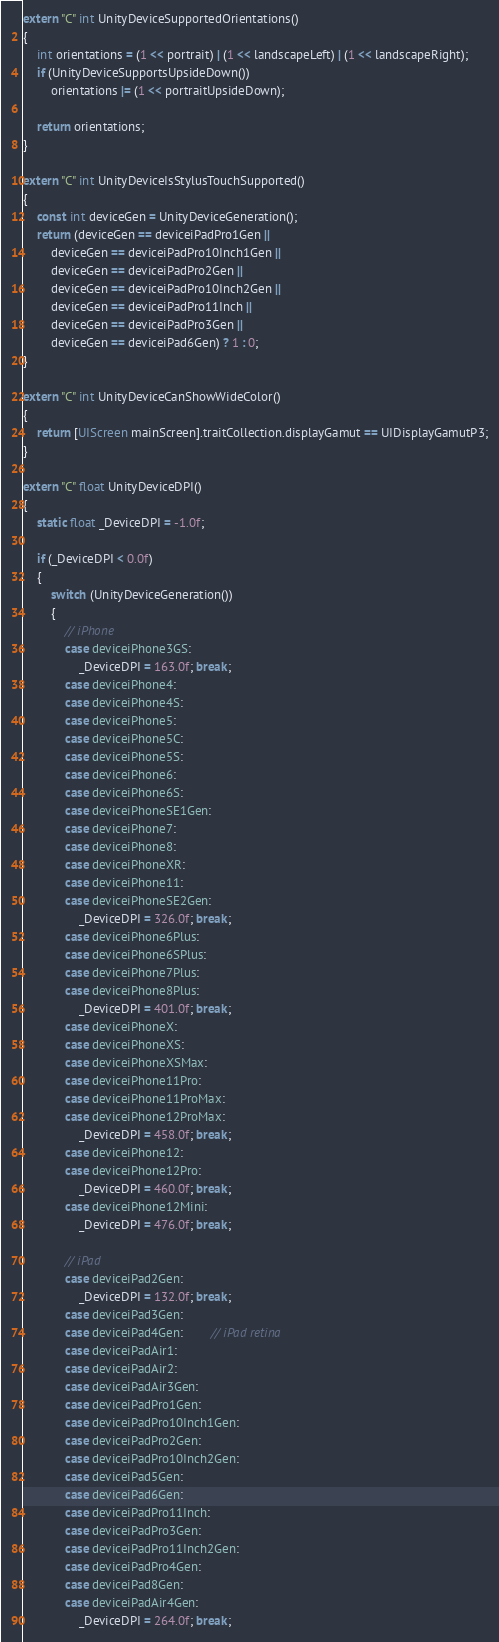Convert code to text. <code><loc_0><loc_0><loc_500><loc_500><_ObjectiveC_>extern "C" int UnityDeviceSupportedOrientations()
{
    int orientations = (1 << portrait) | (1 << landscapeLeft) | (1 << landscapeRight);
    if (UnityDeviceSupportsUpsideDown())
        orientations |= (1 << portraitUpsideDown);

    return orientations;
}

extern "C" int UnityDeviceIsStylusTouchSupported()
{
    const int deviceGen = UnityDeviceGeneration();
    return (deviceGen == deviceiPadPro1Gen ||
        deviceGen == deviceiPadPro10Inch1Gen ||
        deviceGen == deviceiPadPro2Gen ||
        deviceGen == deviceiPadPro10Inch2Gen ||
        deviceGen == deviceiPadPro11Inch ||
        deviceGen == deviceiPadPro3Gen ||
        deviceGen == deviceiPad6Gen) ? 1 : 0;
}

extern "C" int UnityDeviceCanShowWideColor()
{
    return [UIScreen mainScreen].traitCollection.displayGamut == UIDisplayGamutP3;
}

extern "C" float UnityDeviceDPI()
{
    static float _DeviceDPI = -1.0f;

    if (_DeviceDPI < 0.0f)
    {
        switch (UnityDeviceGeneration())
        {
            // iPhone
            case deviceiPhone3GS:
                _DeviceDPI = 163.0f; break;
            case deviceiPhone4:
            case deviceiPhone4S:
            case deviceiPhone5:
            case deviceiPhone5C:
            case deviceiPhone5S:
            case deviceiPhone6:
            case deviceiPhone6S:
            case deviceiPhoneSE1Gen:
            case deviceiPhone7:
            case deviceiPhone8:
            case deviceiPhoneXR:
            case deviceiPhone11:
            case deviceiPhoneSE2Gen:
                _DeviceDPI = 326.0f; break;
            case deviceiPhone6Plus:
            case deviceiPhone6SPlus:
            case deviceiPhone7Plus:
            case deviceiPhone8Plus:
                _DeviceDPI = 401.0f; break;
            case deviceiPhoneX:
            case deviceiPhoneXS:
            case deviceiPhoneXSMax:
            case deviceiPhone11Pro:
            case deviceiPhone11ProMax:
            case deviceiPhone12ProMax:
                _DeviceDPI = 458.0f; break;
            case deviceiPhone12:
            case deviceiPhone12Pro:
                _DeviceDPI = 460.0f; break;
            case deviceiPhone12Mini:
                _DeviceDPI = 476.0f; break;

            // iPad
            case deviceiPad2Gen:
                _DeviceDPI = 132.0f; break;
            case deviceiPad3Gen:
            case deviceiPad4Gen:        // iPad retina
            case deviceiPadAir1:
            case deviceiPadAir2:
            case deviceiPadAir3Gen:
            case deviceiPadPro1Gen:
            case deviceiPadPro10Inch1Gen:
            case deviceiPadPro2Gen:
            case deviceiPadPro10Inch2Gen:
            case deviceiPad5Gen:
            case deviceiPad6Gen:
            case deviceiPadPro11Inch:
            case deviceiPadPro3Gen:
            case deviceiPadPro11Inch2Gen:
            case deviceiPadPro4Gen:
            case deviceiPad8Gen:
            case deviceiPadAir4Gen:
                _DeviceDPI = 264.0f; break;</code> 